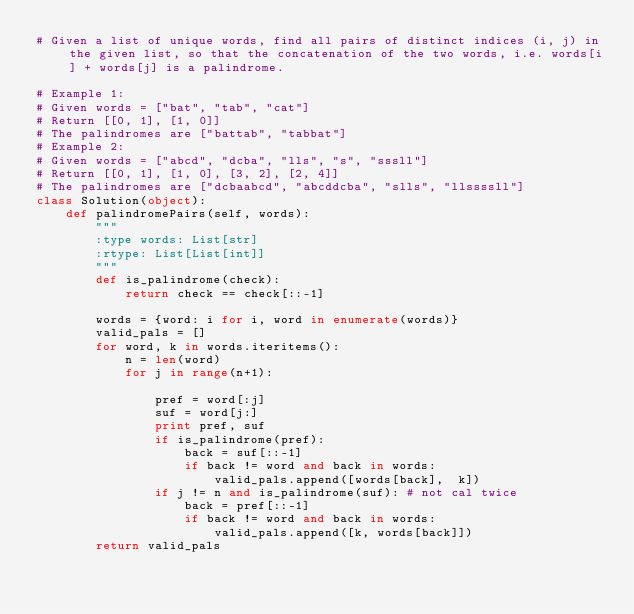<code> <loc_0><loc_0><loc_500><loc_500><_Python_># Given a list of unique words, find all pairs of distinct indices (i, j) in the given list, so that the concatenation of the two words, i.e. words[i] + words[j] is a palindrome.

# Example 1:
# Given words = ["bat", "tab", "cat"]
# Return [[0, 1], [1, 0]]
# The palindromes are ["battab", "tabbat"]
# Example 2:
# Given words = ["abcd", "dcba", "lls", "s", "sssll"]
# Return [[0, 1], [1, 0], [3, 2], [2, 4]]
# The palindromes are ["dcbaabcd", "abcddcba", "slls", "llssssll"]
class Solution(object):
    def palindromePairs(self, words):
        """
        :type words: List[str]
        :rtype: List[List[int]]
        """
        def is_palindrome(check):
            return check == check[::-1]

        words = {word: i for i, word in enumerate(words)}
        valid_pals = []
        for word, k in words.iteritems():
            n = len(word)
            for j in range(n+1):
                
                pref = word[:j]
                suf = word[j:]
                print pref, suf
                if is_palindrome(pref):
                    back = suf[::-1]
                    if back != word and back in words:
                        valid_pals.append([words[back],  k])
                if j != n and is_palindrome(suf): # not cal twice
                    back = pref[::-1]
                    if back != word and back in words:
                        valid_pals.append([k, words[back]])
        return valid_pals
        </code> 